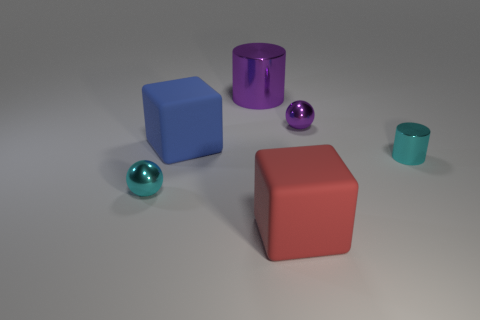Add 4 big shiny things. How many objects exist? 10 Subtract 2 cylinders. How many cylinders are left? 0 Subtract all spheres. How many objects are left? 4 Subtract all brown balls. How many blue cubes are left? 1 Subtract all red things. Subtract all purple cylinders. How many objects are left? 4 Add 3 cyan shiny cylinders. How many cyan shiny cylinders are left? 4 Add 4 small gray metallic things. How many small gray metallic things exist? 4 Subtract 1 purple balls. How many objects are left? 5 Subtract all blue cylinders. Subtract all red blocks. How many cylinders are left? 2 